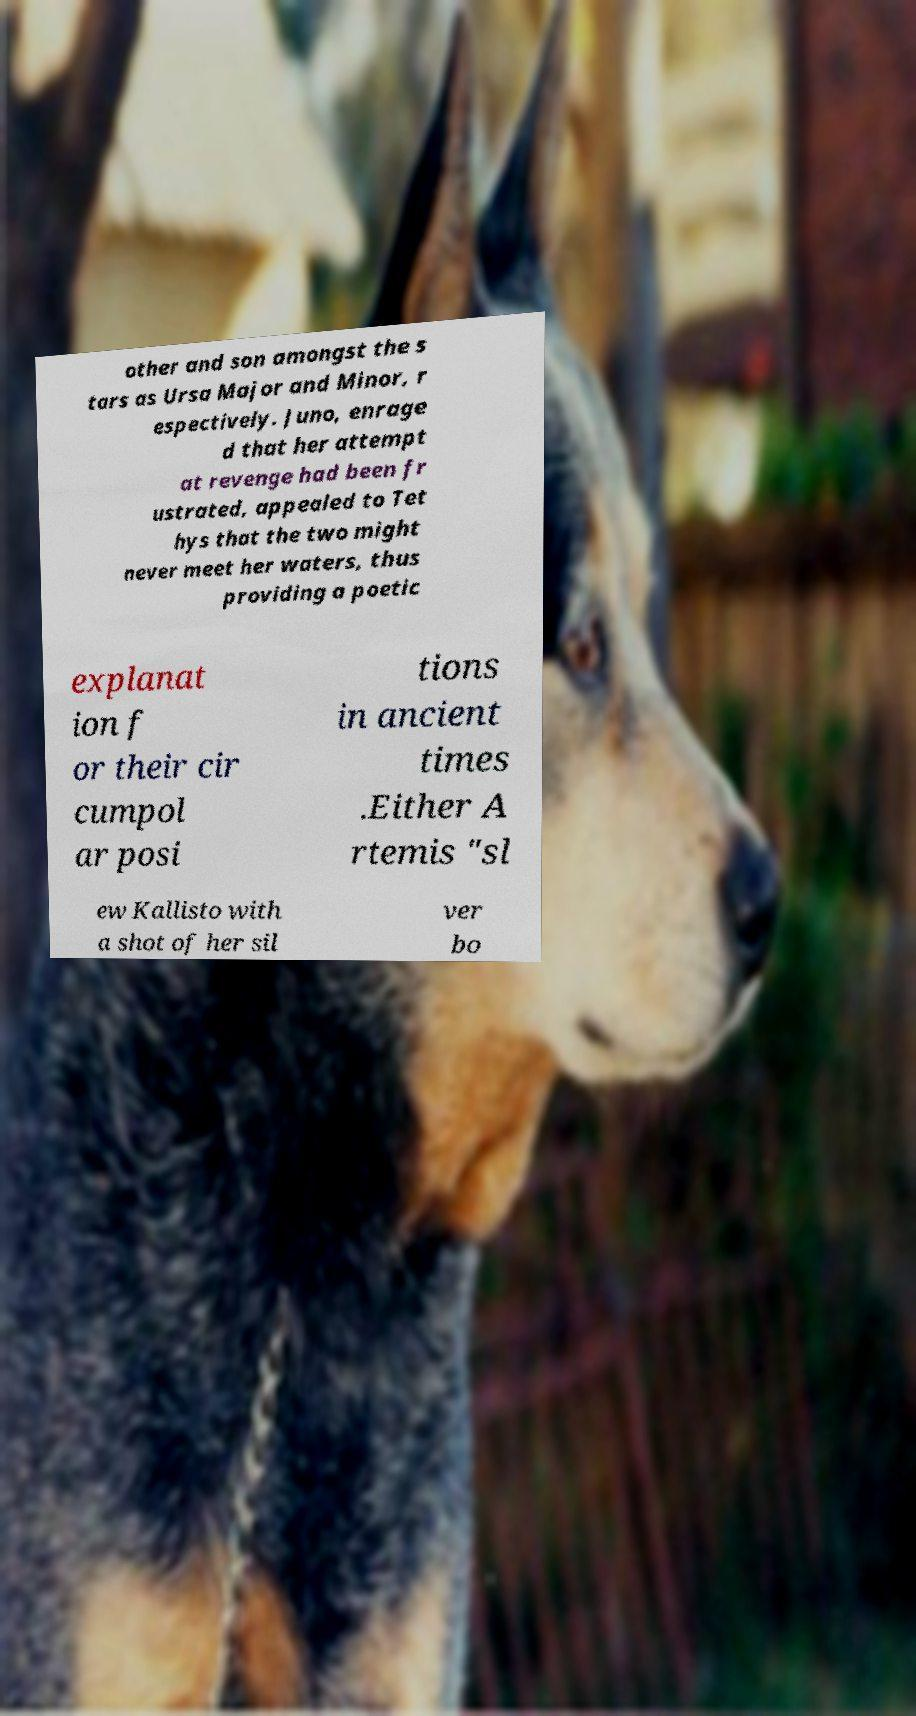I need the written content from this picture converted into text. Can you do that? other and son amongst the s tars as Ursa Major and Minor, r espectively. Juno, enrage d that her attempt at revenge had been fr ustrated, appealed to Tet hys that the two might never meet her waters, thus providing a poetic explanat ion f or their cir cumpol ar posi tions in ancient times .Either A rtemis "sl ew Kallisto with a shot of her sil ver bo 